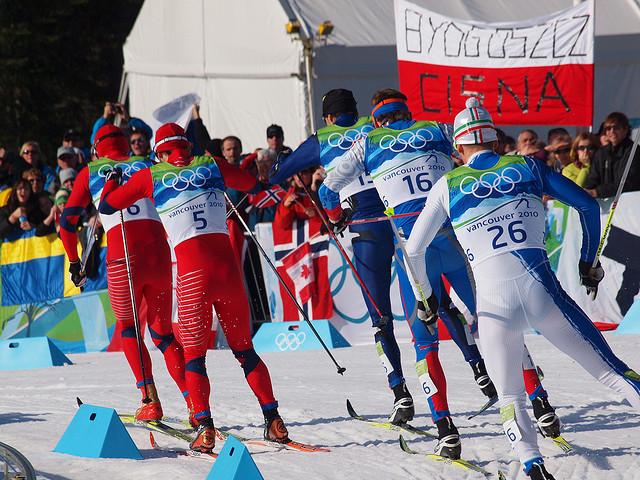Are the people wearing the same colors?
Short answer required. No. How many red skiers do you see?
Write a very short answer. 2. Is this a sport?
Keep it brief. Yes. What colors are the skiers wearing?
Be succinct. Red, white and blue. 